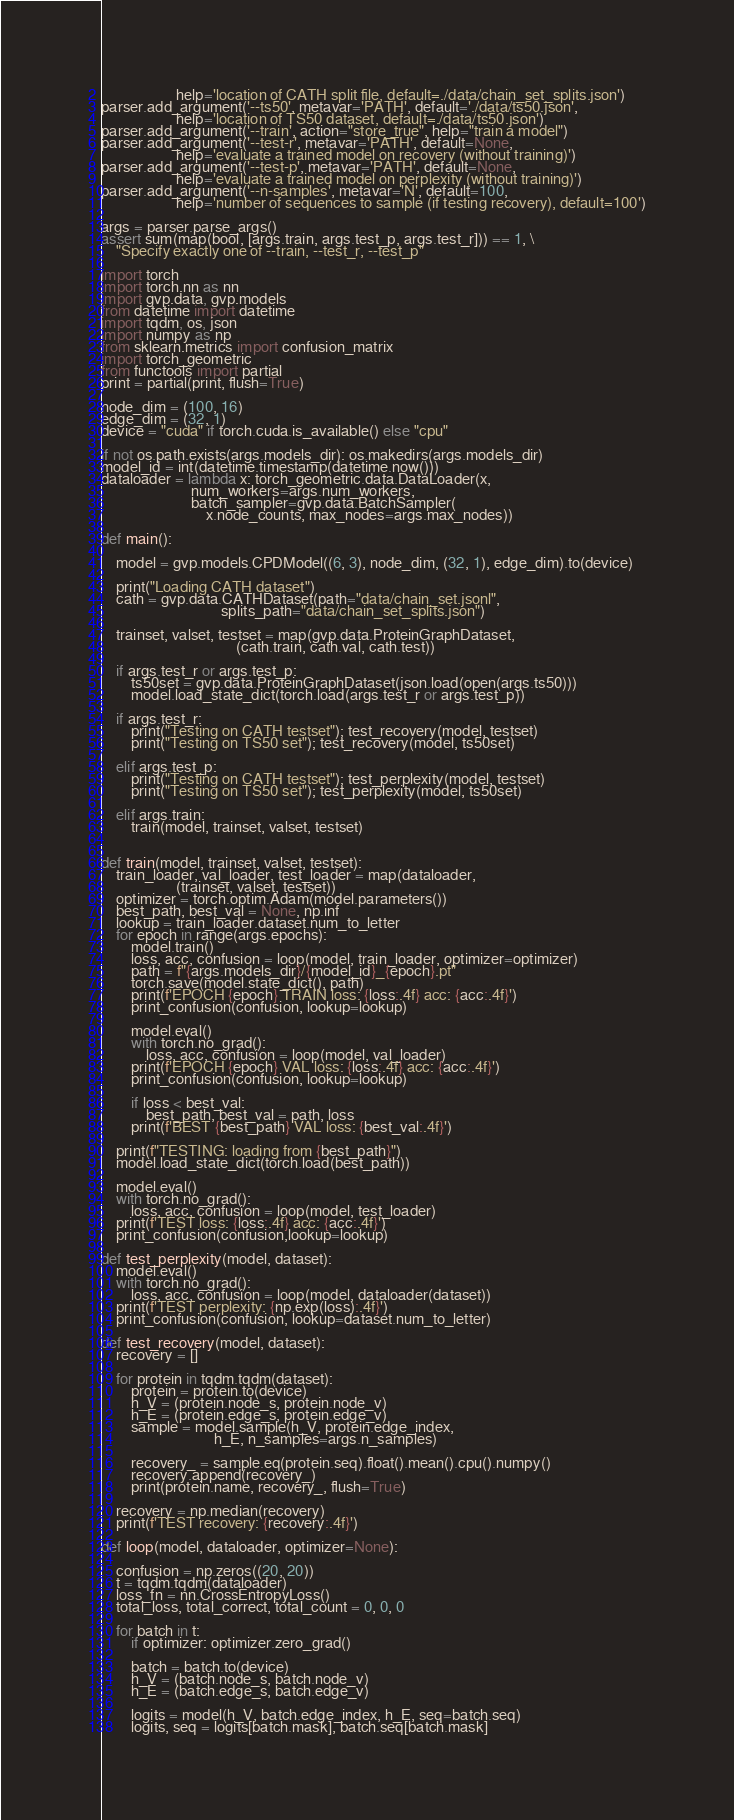Convert code to text. <code><loc_0><loc_0><loc_500><loc_500><_Python_>                    help='location of CATH split file, default=./data/chain_set_splits.json')
parser.add_argument('--ts50', metavar='PATH', default='./data/ts50.json',
                    help='location of TS50 dataset, default=./data/ts50.json')
parser.add_argument('--train', action="store_true", help="train a model")
parser.add_argument('--test-r', metavar='PATH', default=None,
                    help='evaluate a trained model on recovery (without training)')
parser.add_argument('--test-p', metavar='PATH', default=None,
                    help='evaluate a trained model on perplexity (without training)')
parser.add_argument('--n-samples', metavar='N', default=100,
                    help='number of sequences to sample (if testing recovery), default=100')

args = parser.parse_args()
assert sum(map(bool, [args.train, args.test_p, args.test_r])) == 1, \
    "Specify exactly one of --train, --test_r, --test_p"

import torch
import torch.nn as nn
import gvp.data, gvp.models
from datetime import datetime
import tqdm, os, json
import numpy as np
from sklearn.metrics import confusion_matrix
import torch_geometric
from functools import partial
print = partial(print, flush=True)

node_dim = (100, 16)
edge_dim = (32, 1)
device = "cuda" if torch.cuda.is_available() else "cpu"

if not os.path.exists(args.models_dir): os.makedirs(args.models_dir)
model_id = int(datetime.timestamp(datetime.now()))
dataloader = lambda x: torch_geometric.data.DataLoader(x, 
                        num_workers=args.num_workers,
                        batch_sampler=gvp.data.BatchSampler(
                            x.node_counts, max_nodes=args.max_nodes))

def main():
    
    model = gvp.models.CPDModel((6, 3), node_dim, (32, 1), edge_dim).to(device)
    
    print("Loading CATH dataset")
    cath = gvp.data.CATHDataset(path="data/chain_set.jsonl",
                                splits_path="data/chain_set_splits.json")    
    
    trainset, valset, testset = map(gvp.data.ProteinGraphDataset,
                                    (cath.train, cath.val, cath.test))
    
    if args.test_r or args.test_p:
        ts50set = gvp.data.ProteinGraphDataset(json.load(open(args.ts50)))
        model.load_state_dict(torch.load(args.test_r or args.test_p))
    
    if args.test_r:
        print("Testing on CATH testset"); test_recovery(model, testset)
        print("Testing on TS50 set"); test_recovery(model, ts50set)
    
    elif args.test_p:
        print("Testing on CATH testset"); test_perplexity(model, testset)
        print("Testing on TS50 set"); test_perplexity(model, ts50set)
    
    elif args.train:
        train(model, trainset, valset, testset)
    
    
def train(model, trainset, valset, testset):
    train_loader, val_loader, test_loader = map(dataloader,
                    (trainset, valset, testset))
    optimizer = torch.optim.Adam(model.parameters())
    best_path, best_val = None, np.inf
    lookup = train_loader.dataset.num_to_letter
    for epoch in range(args.epochs):
        model.train()
        loss, acc, confusion = loop(model, train_loader, optimizer=optimizer)
        path = f"{args.models_dir}/{model_id}_{epoch}.pt"
        torch.save(model.state_dict(), path)
        print(f'EPOCH {epoch} TRAIN loss: {loss:.4f} acc: {acc:.4f}')
        print_confusion(confusion, lookup=lookup)
        
        model.eval()
        with torch.no_grad():
            loss, acc, confusion = loop(model, val_loader)    
        print(f'EPOCH {epoch} VAL loss: {loss:.4f} acc: {acc:.4f}')
        print_confusion(confusion, lookup=lookup)
        
        if loss < best_val:
            best_path, best_val = path, loss
        print(f'BEST {best_path} VAL loss: {best_val:.4f}')
        
    print(f"TESTING: loading from {best_path}")
    model.load_state_dict(torch.load(best_path))
    
    model.eval()
    with torch.no_grad():
        loss, acc, confusion = loop(model, test_loader)
    print(f'TEST loss: {loss:.4f} acc: {acc:.4f}')
    print_confusion(confusion,lookup=lookup)

def test_perplexity(model, dataset):
    model.eval()
    with torch.no_grad():
        loss, acc, confusion = loop(model, dataloader(dataset))
    print(f'TEST perplexity: {np.exp(loss):.4f}')
    print_confusion(confusion, lookup=dataset.num_to_letter)

def test_recovery(model, dataset):
    recovery = []
    
    for protein in tqdm.tqdm(dataset):
        protein = protein.to(device)
        h_V = (protein.node_s, protein.node_v)
        h_E = (protein.edge_s, protein.edge_v) 
        sample = model.sample(h_V, protein.edge_index, 
                              h_E, n_samples=args.n_samples)
        
        recovery_ = sample.eq(protein.seq).float().mean().cpu().numpy()
        recovery.append(recovery_)
        print(protein.name, recovery_, flush=True)

    recovery = np.median(recovery)
    print(f'TEST recovery: {recovery:.4f}')
    
def loop(model, dataloader, optimizer=None):

    confusion = np.zeros((20, 20))
    t = tqdm.tqdm(dataloader)
    loss_fn = nn.CrossEntropyLoss()
    total_loss, total_correct, total_count = 0, 0, 0
    
    for batch in t:
        if optimizer: optimizer.zero_grad()
    
        batch = batch.to(device)
        h_V = (batch.node_s, batch.node_v)
        h_E = (batch.edge_s, batch.edge_v)
        
        logits = model(h_V, batch.edge_index, h_E, seq=batch.seq)
        logits, seq = logits[batch.mask], batch.seq[batch.mask]</code> 